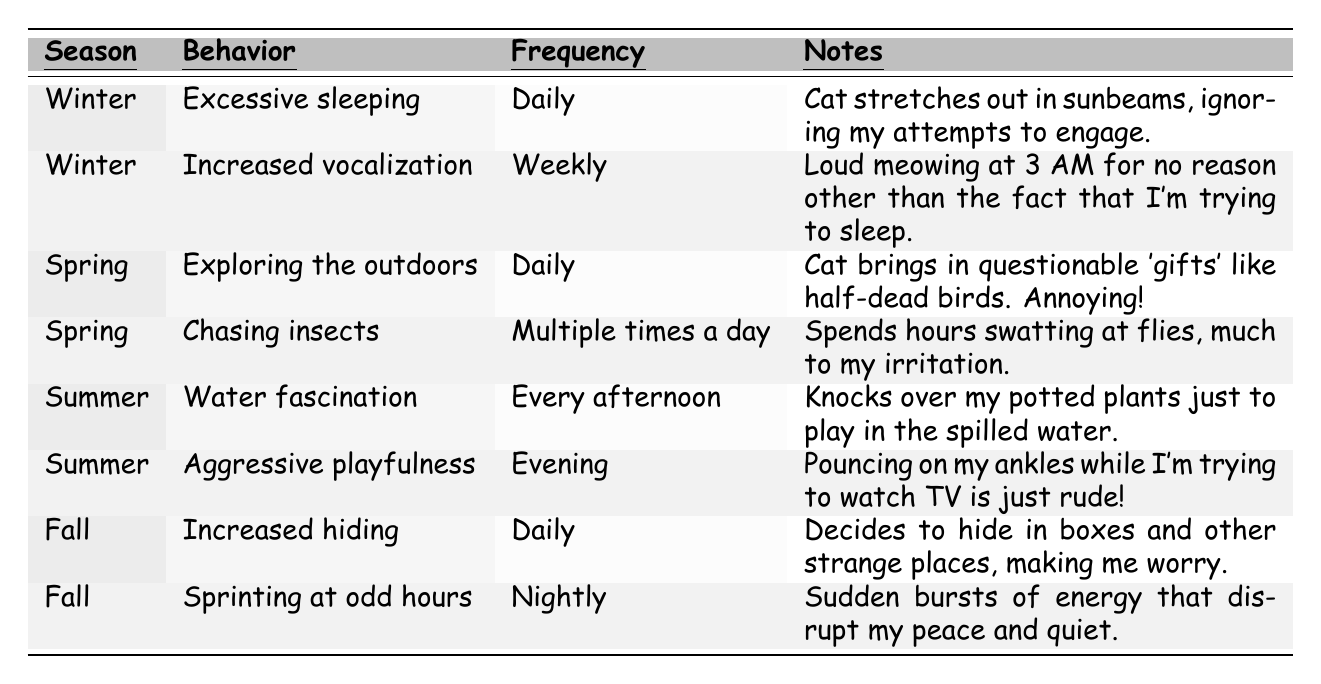What behavior is associated with Winter? The table lists two behaviors for Winter: excessive sleeping and increased vocalization.
Answer: Excessive sleeping and increased vocalization How often does the cat chase insects in Spring? According to the table, the behavior of chasing insects occurs multiple times a day in Spring.
Answer: Multiple times a day Does the cat show increased hiding behavior during Fall? The table indicates that increased hiding is a behavior observed in Fall.
Answer: Yes What season is characterized by aggressive playfulness? The table shows that aggressive playfulness occurs in the Summer season.
Answer: Summer How many behaviors are listed for Spring? The table lists two behaviors for Spring: exploring the outdoors and chasing insects.
Answer: Two Which behavior is linked to the Summer season? Water fascination and aggressive playfulness are the behaviors linked to Summer.
Answer: Water fascination and aggressive playfulness In which season does the cat exhibit excessive sleeping? The table specifies that excessive sleeping is exhibited in Winter.
Answer: Winter What is the frequency of increased vocalization in Winter? The table states that increased vocalization occurs weekly during Winter.
Answer: Weekly How frequently does the cat display the behavior of sprinting at odd hours? The behavior of sprinting at odd hours is noted to occur nightly in Fall.
Answer: Nightly What is the total number of unique behaviors observed across all seasons? The table lists a total of eight unique behaviors spread across four seasons.
Answer: Eight Which season has the most frequent behaviors involving exploring or chasing? Both behaviors related to exploring (in Spring) and chasing (in Spring) occur daily. Spring is the season with the most frequent behaviors.
Answer: Spring In which season does the cat's behavior interrupt sleep the most? The table shows increased vocalization in Winter occurs weekly, notably disturbing sleep.
Answer: Winter What is the main annoyance related to the cat's water fascination in Summer? The table notes that the cat knocks over potted plants to play in spilled water, creating a mess.
Answer: Knocking over potted plants How does the frequency of increased hiding in Fall compare to excessive sleeping? Both increased hiding and excessive sleeping occur daily, making them equal in frequency.
Answer: Equal frequency 